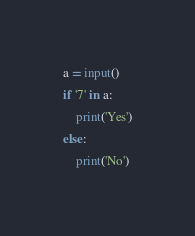<code> <loc_0><loc_0><loc_500><loc_500><_Python_>a = input()
if '7' in a:
    print('Yes')
else:
    print('No')</code> 